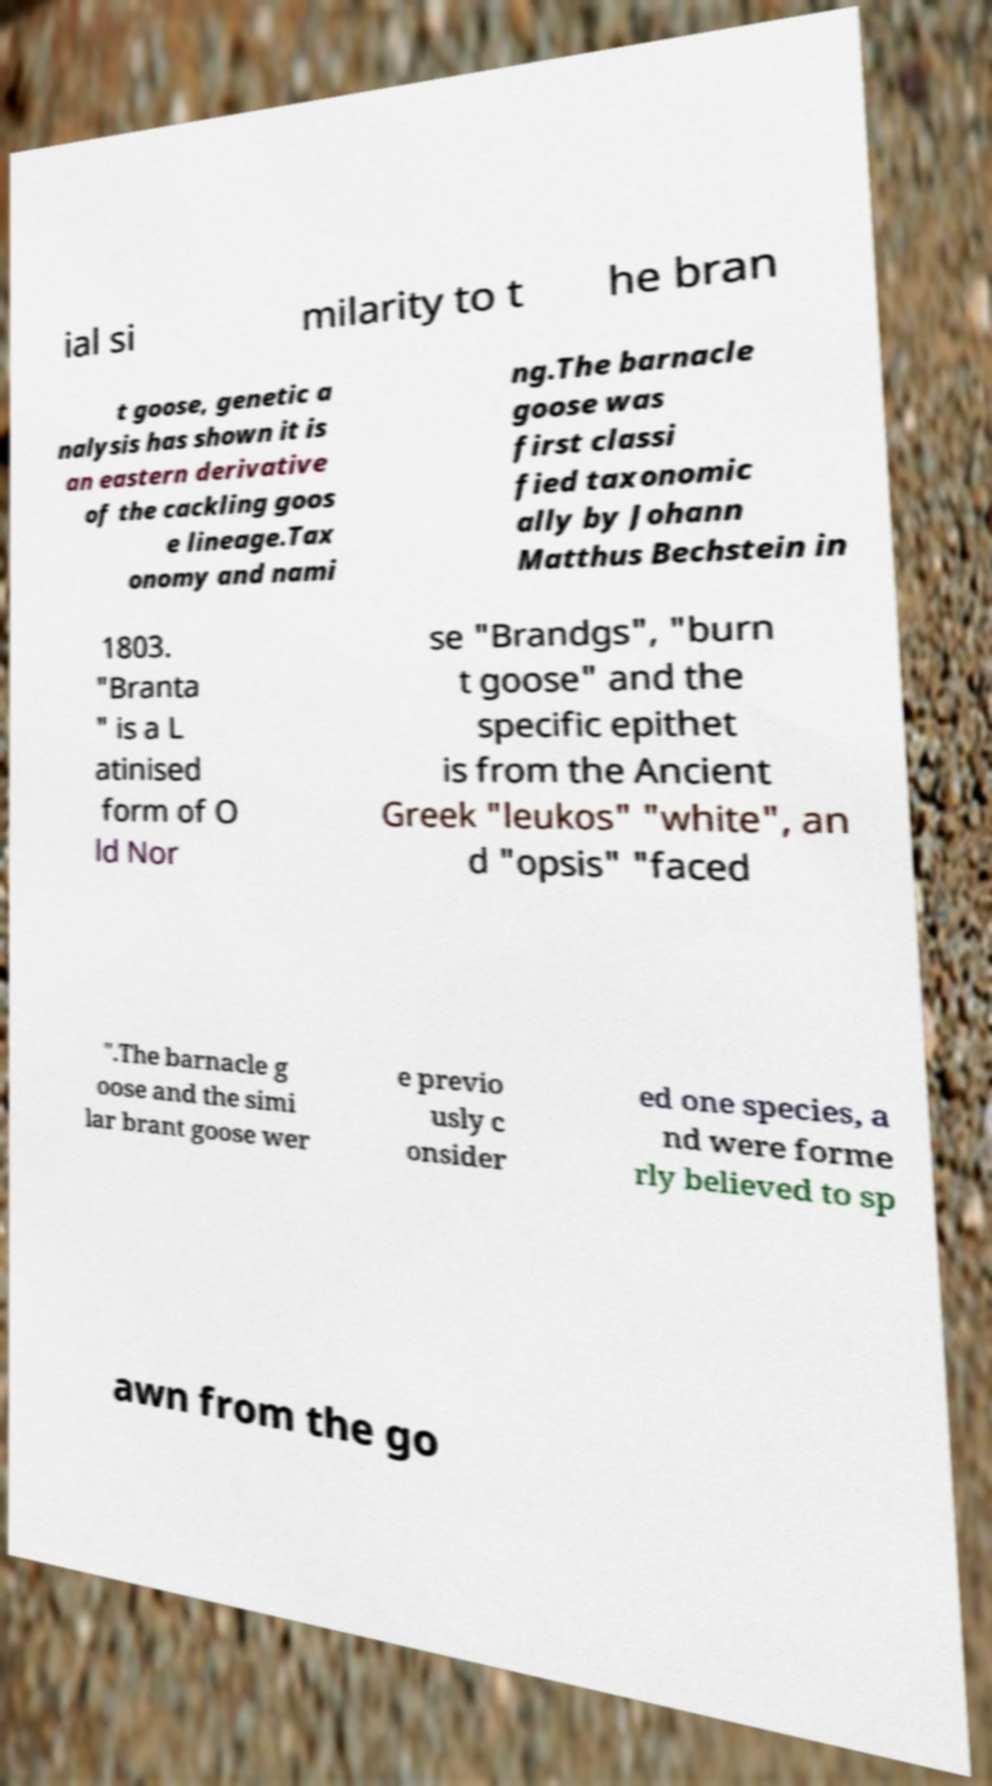Can you accurately transcribe the text from the provided image for me? ial si milarity to t he bran t goose, genetic a nalysis has shown it is an eastern derivative of the cackling goos e lineage.Tax onomy and nami ng.The barnacle goose was first classi fied taxonomic ally by Johann Matthus Bechstein in 1803. "Branta " is a L atinised form of O ld Nor se "Brandgs", "burn t goose" and the specific epithet is from the Ancient Greek "leukos" "white", an d "opsis" "faced ".The barnacle g oose and the simi lar brant goose wer e previo usly c onsider ed one species, a nd were forme rly believed to sp awn from the go 